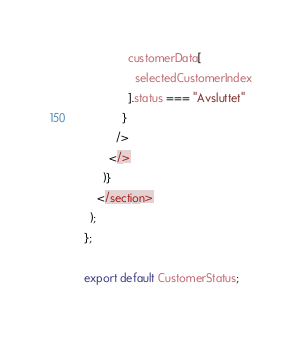<code> <loc_0><loc_0><loc_500><loc_500><_JavaScript_>              customerData[
                selectedCustomerIndex
              ].status === "Avsluttet"
            }
          />
        </>
      )}
    </section>
  );
};

export default CustomerStatus;
</code> 